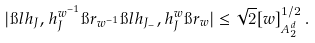<formula> <loc_0><loc_0><loc_500><loc_500>| \i l h _ { J } , h _ { J } ^ { w ^ { - 1 } } \i r _ { w ^ { - 1 } } \i l h _ { J _ { - } } , h _ { J } ^ { w } \i r _ { w } | \leq \sqrt { 2 } [ w ] _ { A _ { 2 } ^ { d } } ^ { 1 / 2 } \, .</formula> 